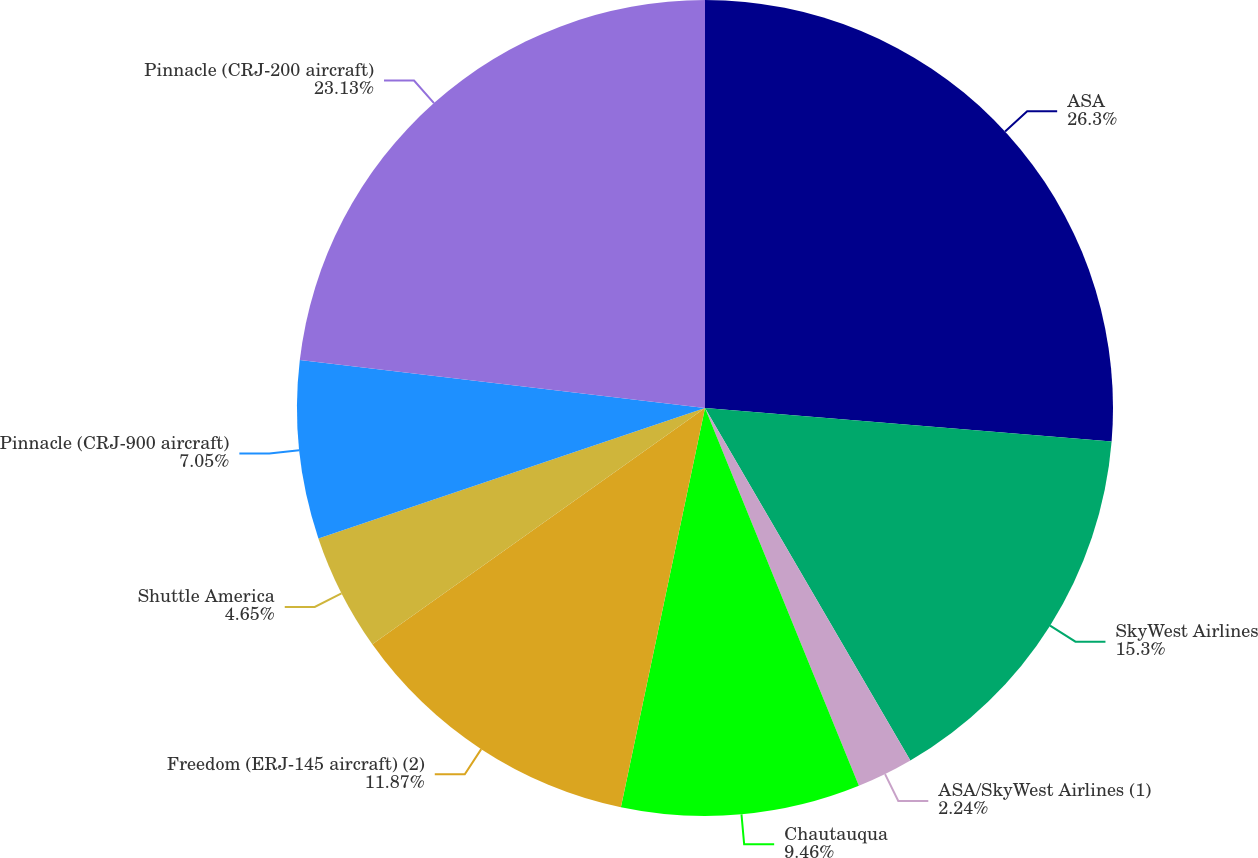Convert chart. <chart><loc_0><loc_0><loc_500><loc_500><pie_chart><fcel>ASA<fcel>SkyWest Airlines<fcel>ASA/SkyWest Airlines (1)<fcel>Chautauqua<fcel>Freedom (ERJ-145 aircraft) (2)<fcel>Shuttle America<fcel>Pinnacle (CRJ-900 aircraft)<fcel>Pinnacle (CRJ-200 aircraft)<nl><fcel>26.31%<fcel>15.3%<fcel>2.24%<fcel>9.46%<fcel>11.87%<fcel>4.65%<fcel>7.05%<fcel>23.13%<nl></chart> 